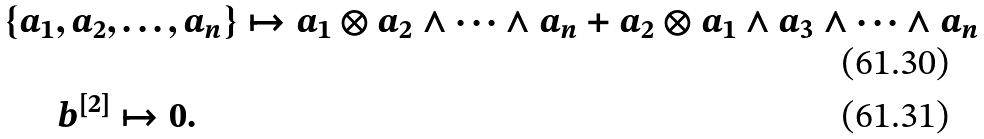Convert formula to latex. <formula><loc_0><loc_0><loc_500><loc_500>& \{ a _ { 1 } , a _ { 2 } , \dots , a _ { n } \} \mapsto a _ { 1 } \otimes a _ { 2 } \wedge \dots \wedge a _ { n } + a _ { 2 } \otimes a _ { 1 } \wedge a _ { 3 } \wedge \dots \wedge a _ { n } \\ & \quad \ \ b ^ { [ 2 ] } \mapsto 0 .</formula> 